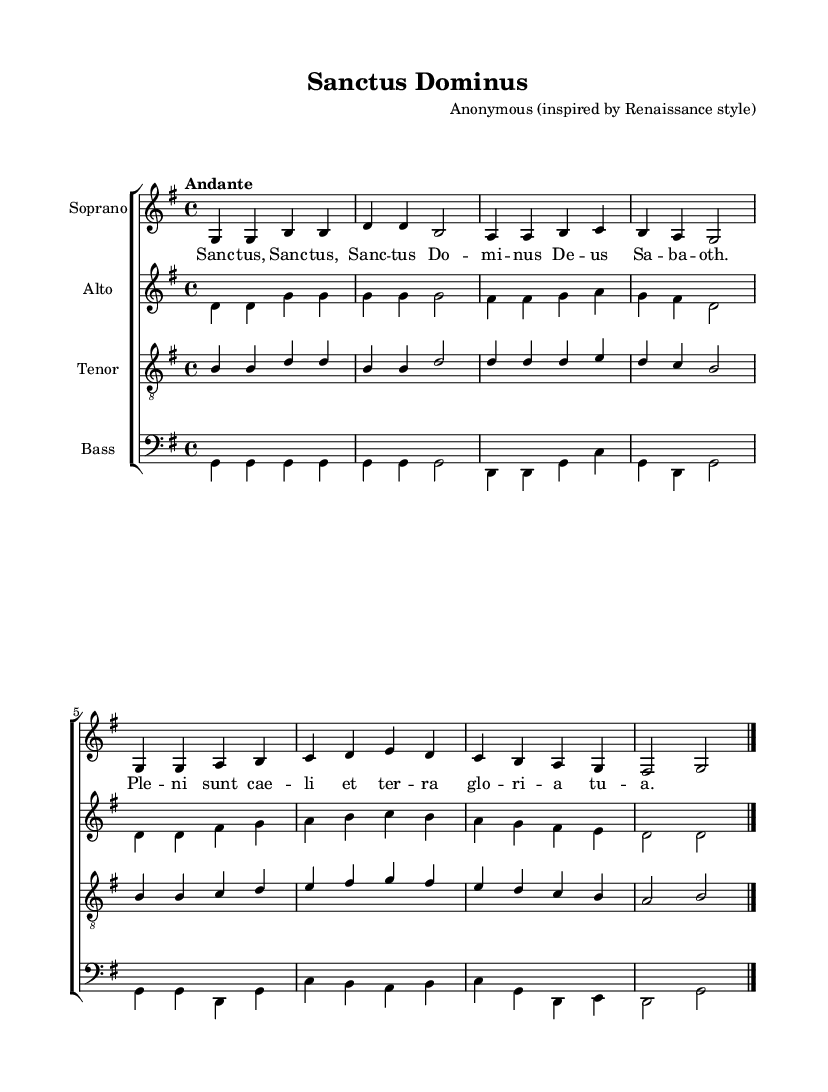What is the key signature of this music? The key signature is G major, which has one sharp (F#). This can be identified at the beginning of the staff where the sharps are indicated.
Answer: G major What is the time signature of the piece? The time signature is 4/4, which is indicated at the beginning of the staff, showing that there are four beats per measure and the quarter note gets one beat.
Answer: 4/4 What is the tempo marking for the composition? The tempo marking "Andante" is noted above the staff, suggesting a moderate walking pace. This helps performers understand the desired speed of the piece.
Answer: Andante How many measures are there in the soprano part? By counting visually, we see eight measures in the soprano part, as indicated by the grouping of bar lines.
Answer: 8 Which voices are present in this choral composition? The composition features four voices: Soprano, Alto, Tenor, and Bass. Each voice is clearly labeled in their respective staff, detailing the different vocal ranges included.
Answer: Soprano, Alto, Tenor, Bass What is the text of the lyrics sung in the piece? The lyrics are "Sanctus, Sanctus, Sanctus Dominus Deus Sabaoth. Pleni sunt caeli et terra gloria tua." This can be found underneath the soprano staff, showing the words matched with the corresponding notes.
Answer: Sanctus, Sanctus, Sanctus Dominus Deus Sabaoth. Pleni sunt caeli et terra gloria tua In which style is this composition inspired? The composer is noted as "Anonymous (inspired by Renaissance style)", indicating that the overall harmonic structure and melodic lines reflect characteristics typical of Renaissance music.
Answer: Renaissance style 